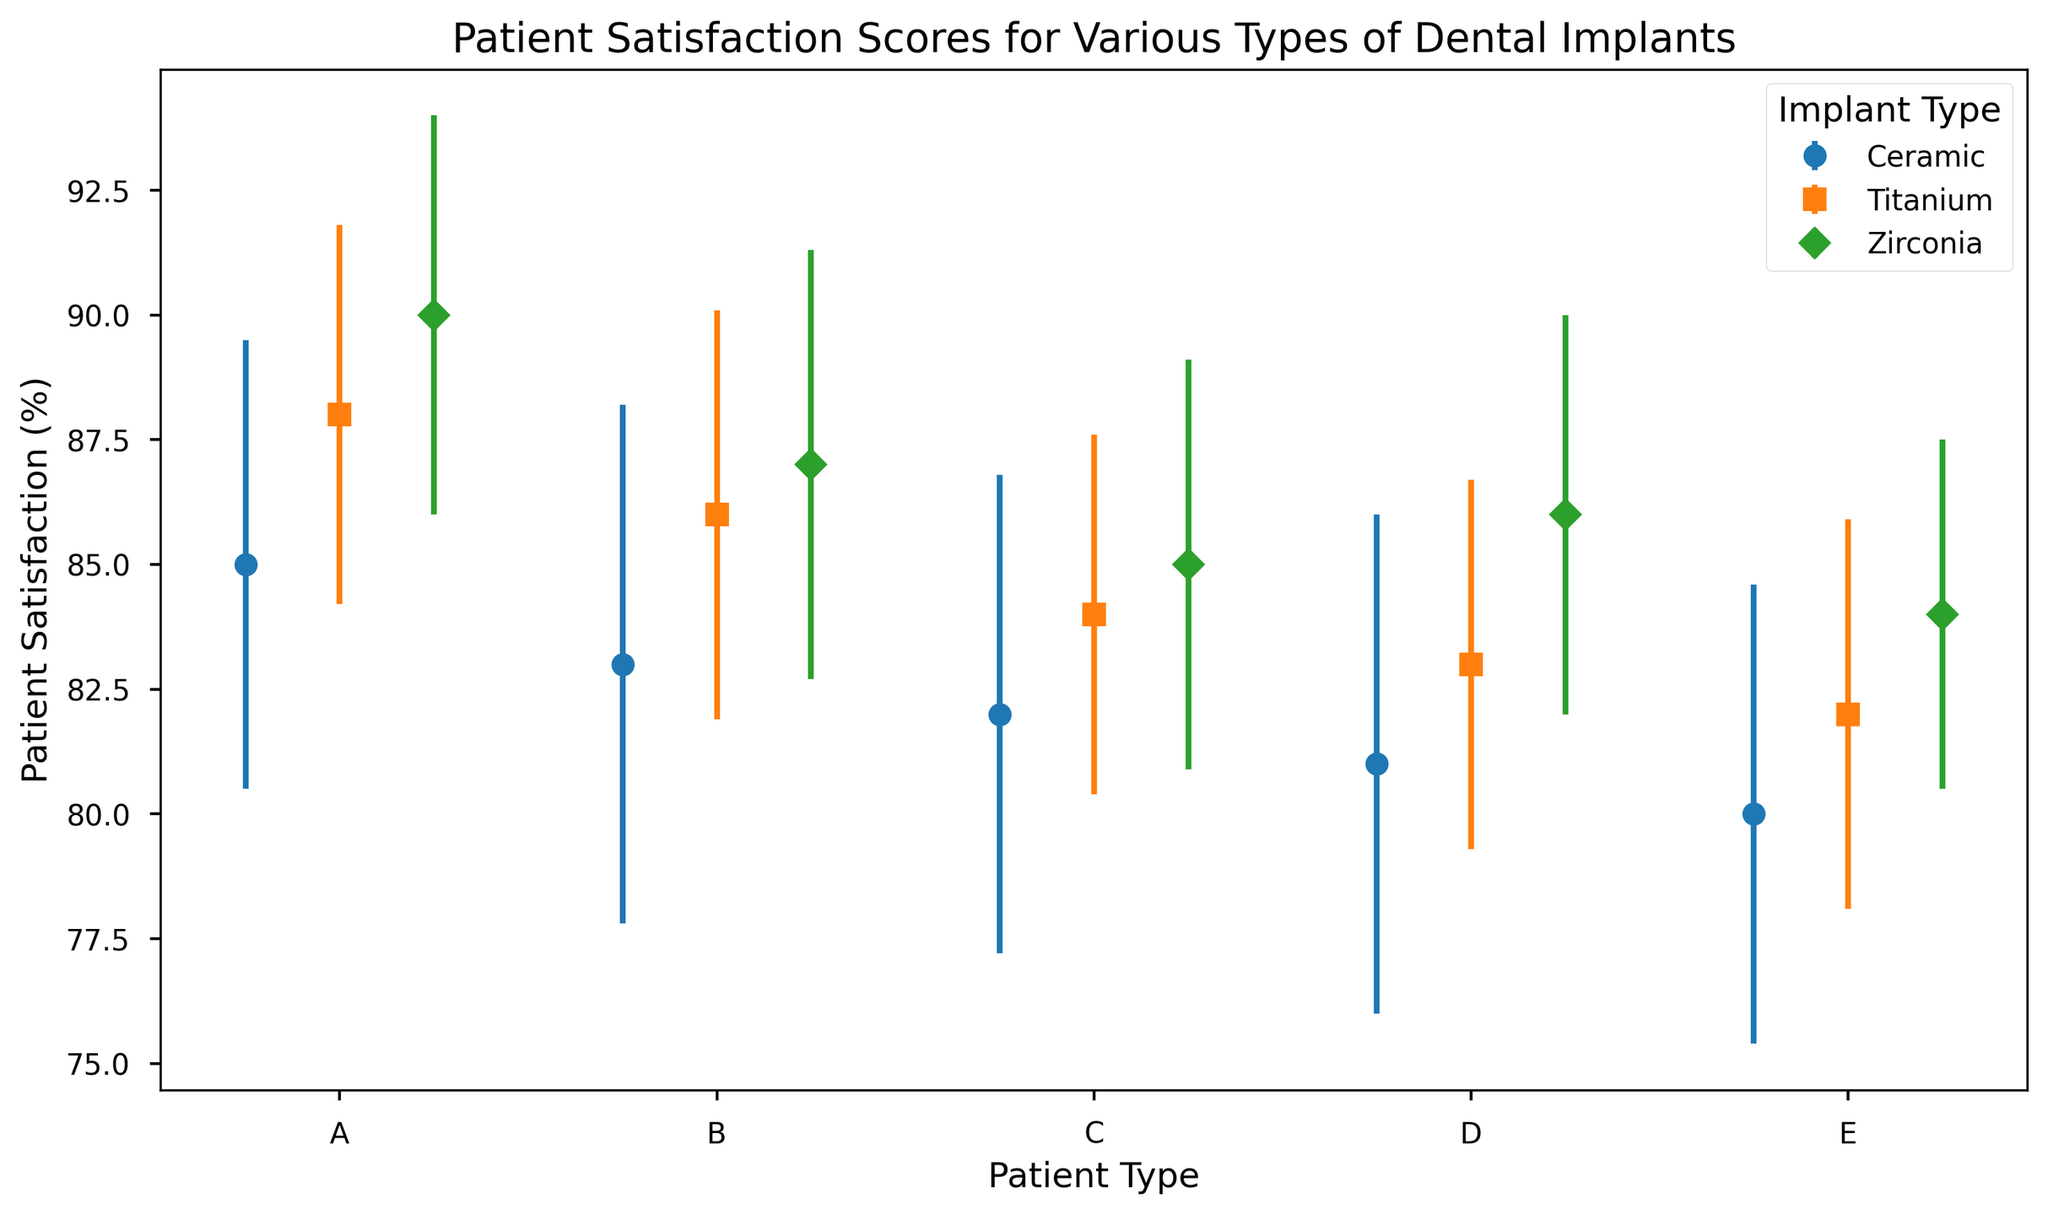What is the average patient satisfaction score for Patient Type A across all implant types? The satisfaction scores for Patient Type A are 85 (Ceramic), 88 (Titanium), and 90 (Zirconia). The average satisfaction score is (85 + 88 + 90) / 3 = 87.67
Answer: 87.67 Which implant type has the highest satisfaction score for Patient Type B? The satisfaction scores for Patient Type B are 83 (Ceramic), 86 (Titanium), and 87 (Zirconia). The highest score among these is 87, which is for Zirconia implants
Answer: Zirconia Of Patient Type C, which implant type has the smallest error bar, and what is that standard deviation? The standard deviations are 4.8 (Ceramic), 3.6 (Titanium), and 4.1 (Zirconia). The smallest error bar is for Titanium implants with a standard deviation of 3.6
Answer: Titanium, 3.6 Does Patient Type E have a higher satisfaction score for Ceramic implants or Titanium implants? The satisfaction scores for Patient Type E are 80 (Ceramic) and 82 (Titanium). 82 is higher than 80
Answer: Titanium Which patient type has the overall lowest satisfaction score regardless of implant type? The lowest satisfaction scores among all patient types are 85 (A), 83 (B), 82 (C), 81 (D), and 80 (E). The lowest of these is 80 for Patient Type E
Answer: E For Patient Type D, what is the difference between the highest and lowest satisfaction scores? The satisfaction scores for Patient Type D are 81 (Ceramic), 83 (Titanium), and 86 (Zirconia). The difference is 86 - 81 = 5
Answer: 5 Is there any patient type where the satisfaction score for Ceramic implants is higher than the score for Titanium implants? For Patient Types A, B, C, D, and E, the satisfaction scores for Ceramic vs. Titanium implants are 85 vs. 88, 83 vs. 86, 82 vs. 84, 81 vs. 83, and 80 vs. 82 respectively. In all cases, Ceramic scores are lower than Titanium
Answer: No Which implant type shows the most consistent satisfaction scores (i.e., smallest average standard deviation) across all patient types? The average standard deviations are (4.5 + 5.2 + 4.8 + 5.0 + 4.6)/5 = 4.82 for Ceramic, (3.8 + 4.1 + 3.6 + 3.7 + 3.9)/5 = 3.82 for Titanium, and (4.0 + 4.3 + 4.1 + 4.0 + 3.5)/5 = 3.98 for Zirconia. The smallest average standard deviation is for Titanium
Answer: Titanium 